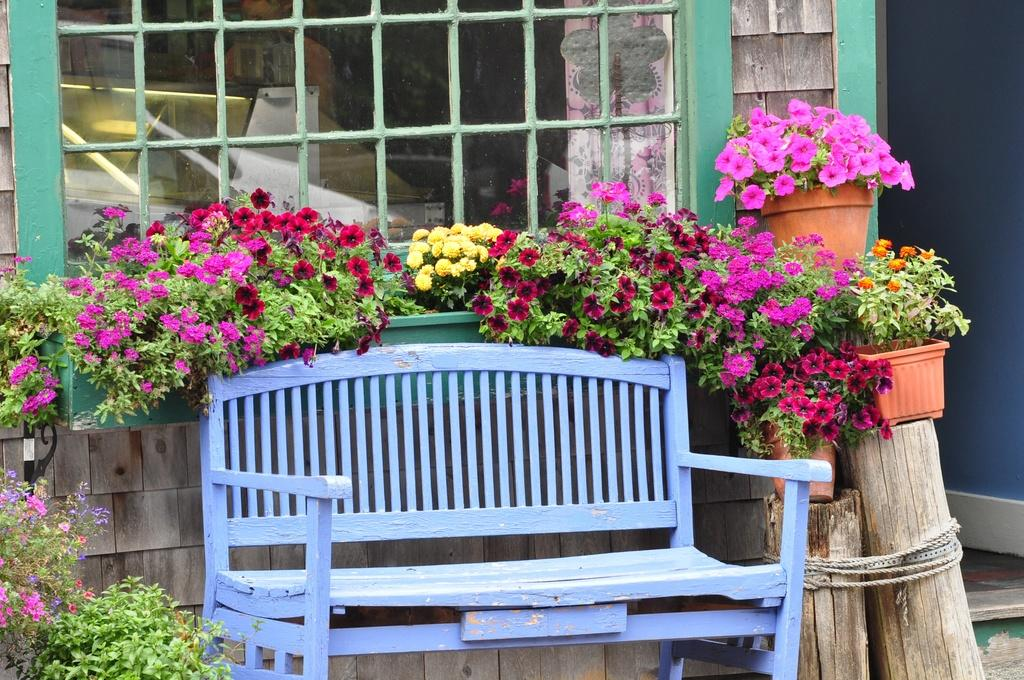What type of bench is in the image? There is a blue color wooden bench in the image. What else can be seen in the image besides the bench? There are flower plants in flower pots and a glass window in the image. How is the wooden trunk secured in the image? The wooden trunk is tied up with a rope in the image. Can you hear the wooden bench laughing in the image? There is no sound or indication of laughter in the image; it is a still image of a wooden bench, flower plants, a glass window, and a wooden trunk tied up with a rope. 